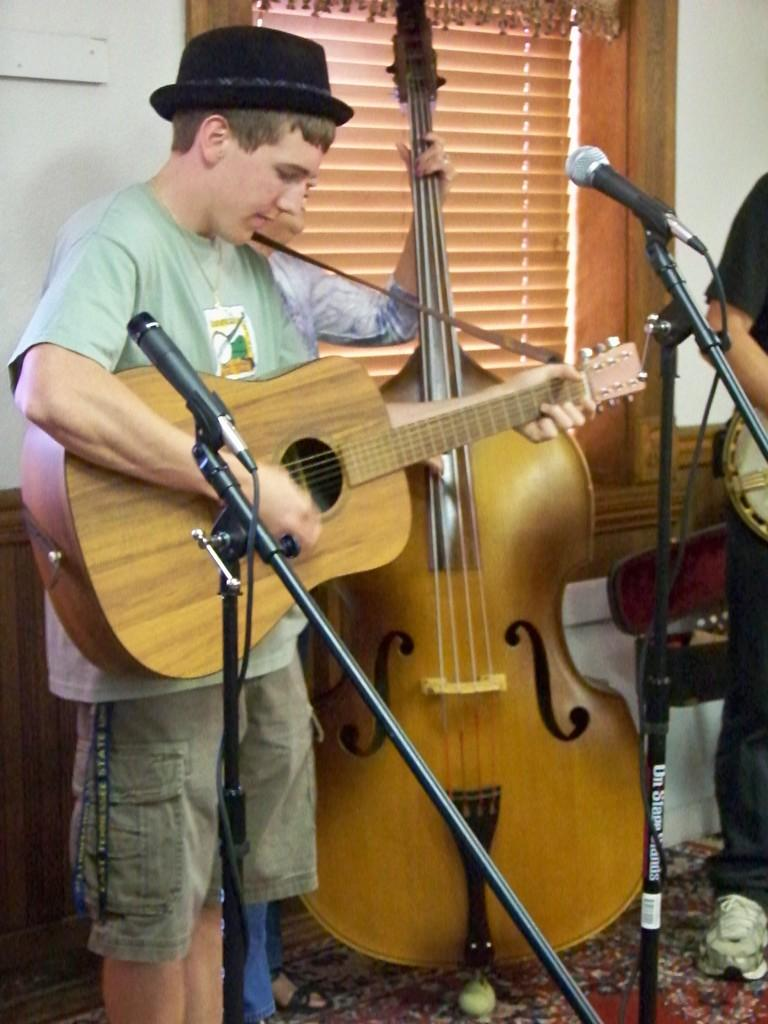What are the people in the image doing? The people in the image are playing musical instruments. What can be seen in the background of the image? There is a wall in the background of the image. What object is located in the middle of the image? There is a microphone in the middle of the image. What degree does the example in the image have? There is no example or degree mentioned in the image; it features people playing musical instruments and a microphone. 